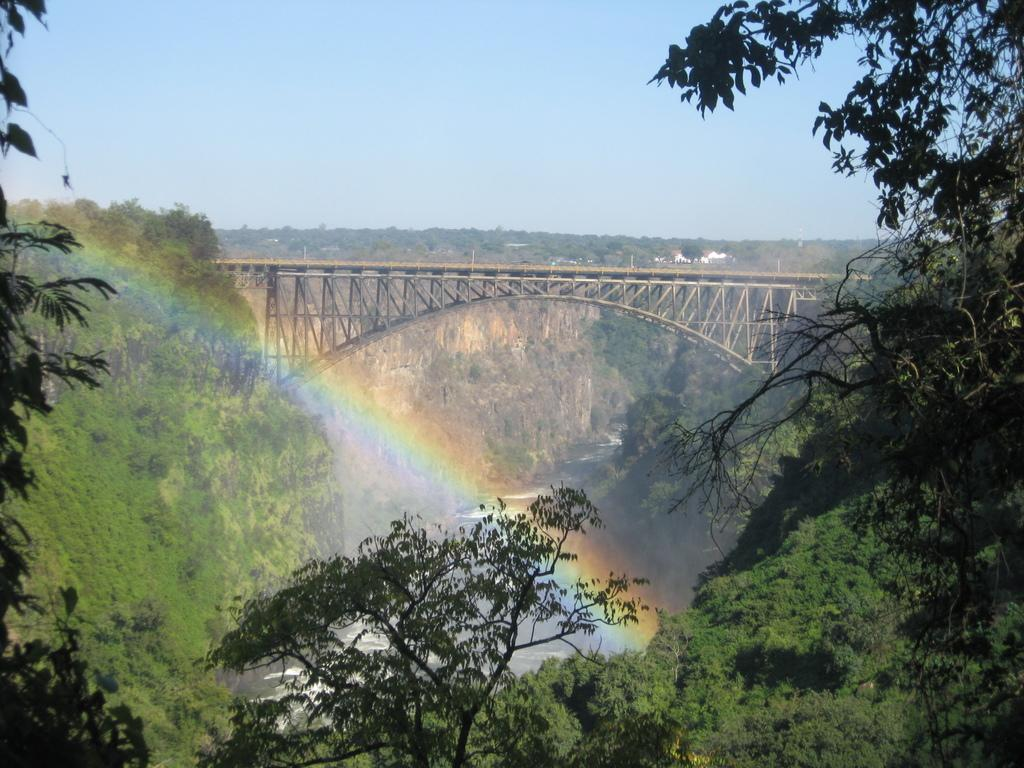What type of vegetation is present at the bottom of the image? There are trees at the bottom of the image. What can be seen on the cliff in the background of the image? There are trees on a cliff in the background of the image. What natural element is visible in the background of the image? There is water visible in the background of the image. What natural phenomenon can be seen on the left side of the image? There is a rainbow on the left side of the image. What type of structure is present in the background of the image? There is a bridge in the background of the image. What type of buildings are visible in the background of the image? There are houses in the background of the image. What is visible in the sky in the background of the image? The sky is visible in the background of the image. What type of iron is being used to make shoes in the image? There is no iron or shoe-making activity present in the image. How many clovers can be seen growing in the image? There are no clovers visible in the image. 